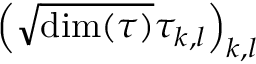Convert formula to latex. <formula><loc_0><loc_0><loc_500><loc_500>\left ( { \sqrt { \dim ( \tau ) } } \tau _ { k , l } \right ) _ { k , l }</formula> 